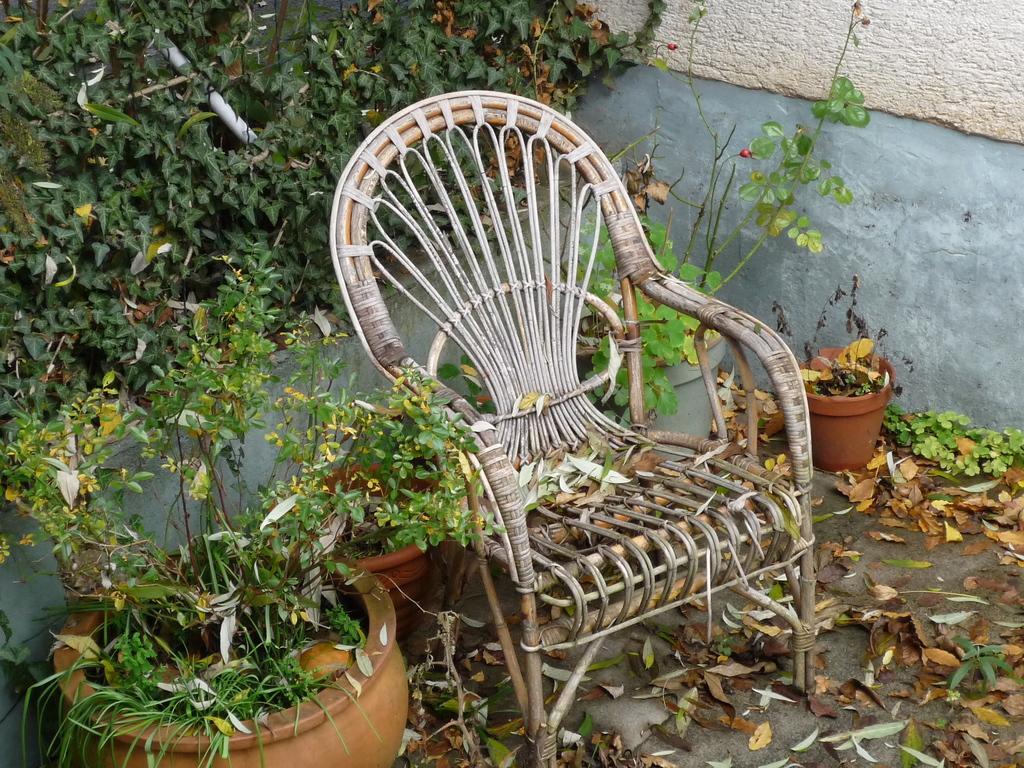Can you describe this image briefly? In this image I can see a chair. beside the chair there are some flower pots and the wall. 